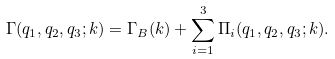Convert formula to latex. <formula><loc_0><loc_0><loc_500><loc_500>\Gamma ( q _ { 1 } , q _ { 2 } , q _ { 3 } ; { k } ) = \Gamma _ { B } ( { k } ) + \sum _ { i = 1 } ^ { 3 } \Pi _ { i } ( q _ { 1 } , q _ { 2 } , q _ { 3 } ; { k } ) .</formula> 